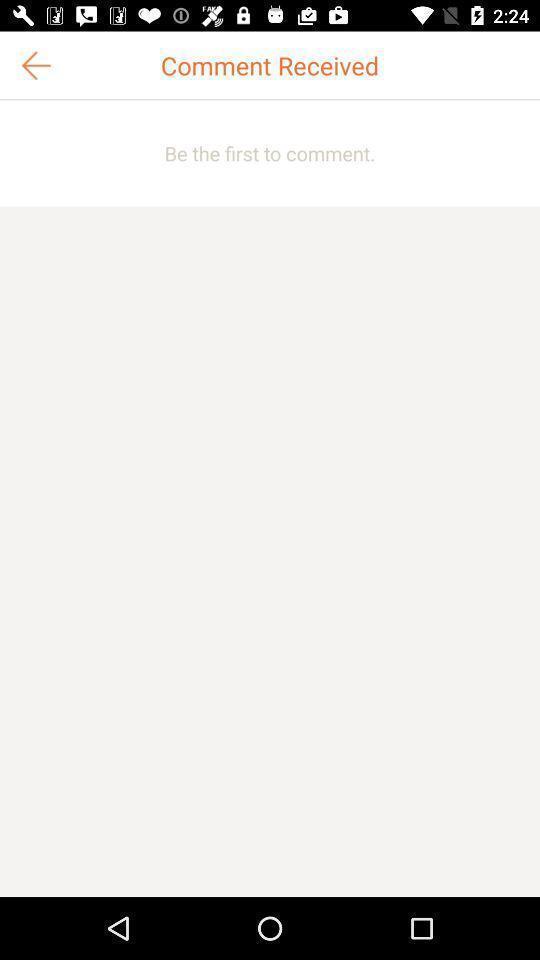What can you discern from this picture? Page displays to comment in app. 